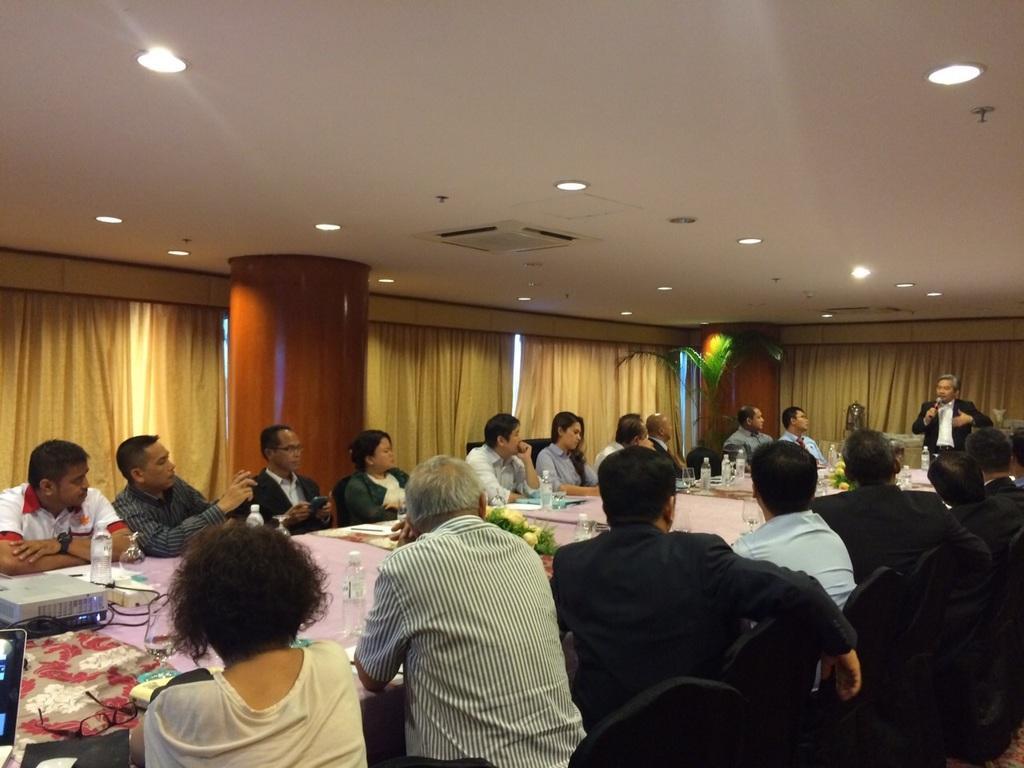In one or two sentences, can you explain what this image depicts? A group of people gathered around a table sitting in chairs. There is man standing and speaking to them. There are some bottles and water glasses on table. The room has false ceiling with some rows of light and AC vent. 